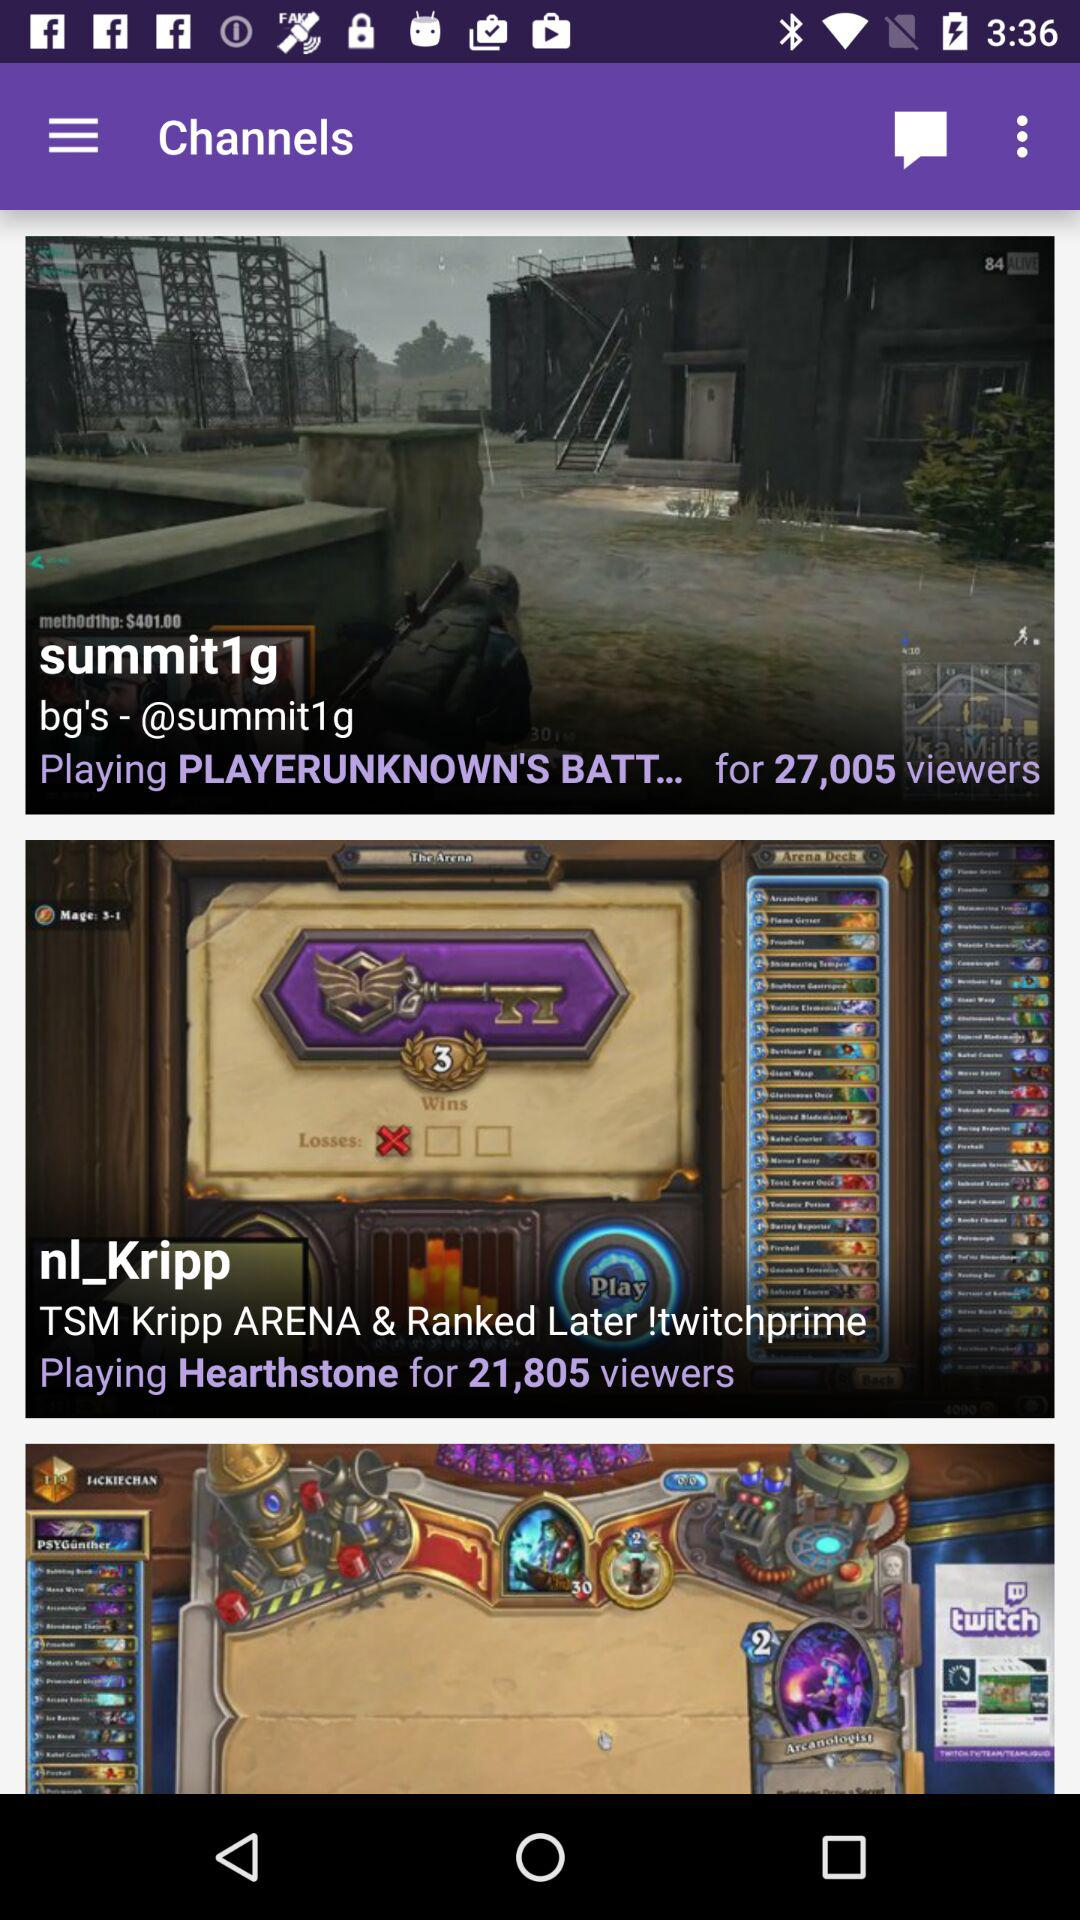How many viewers does the first stream have?
Answer the question using a single word or phrase. 27,005 